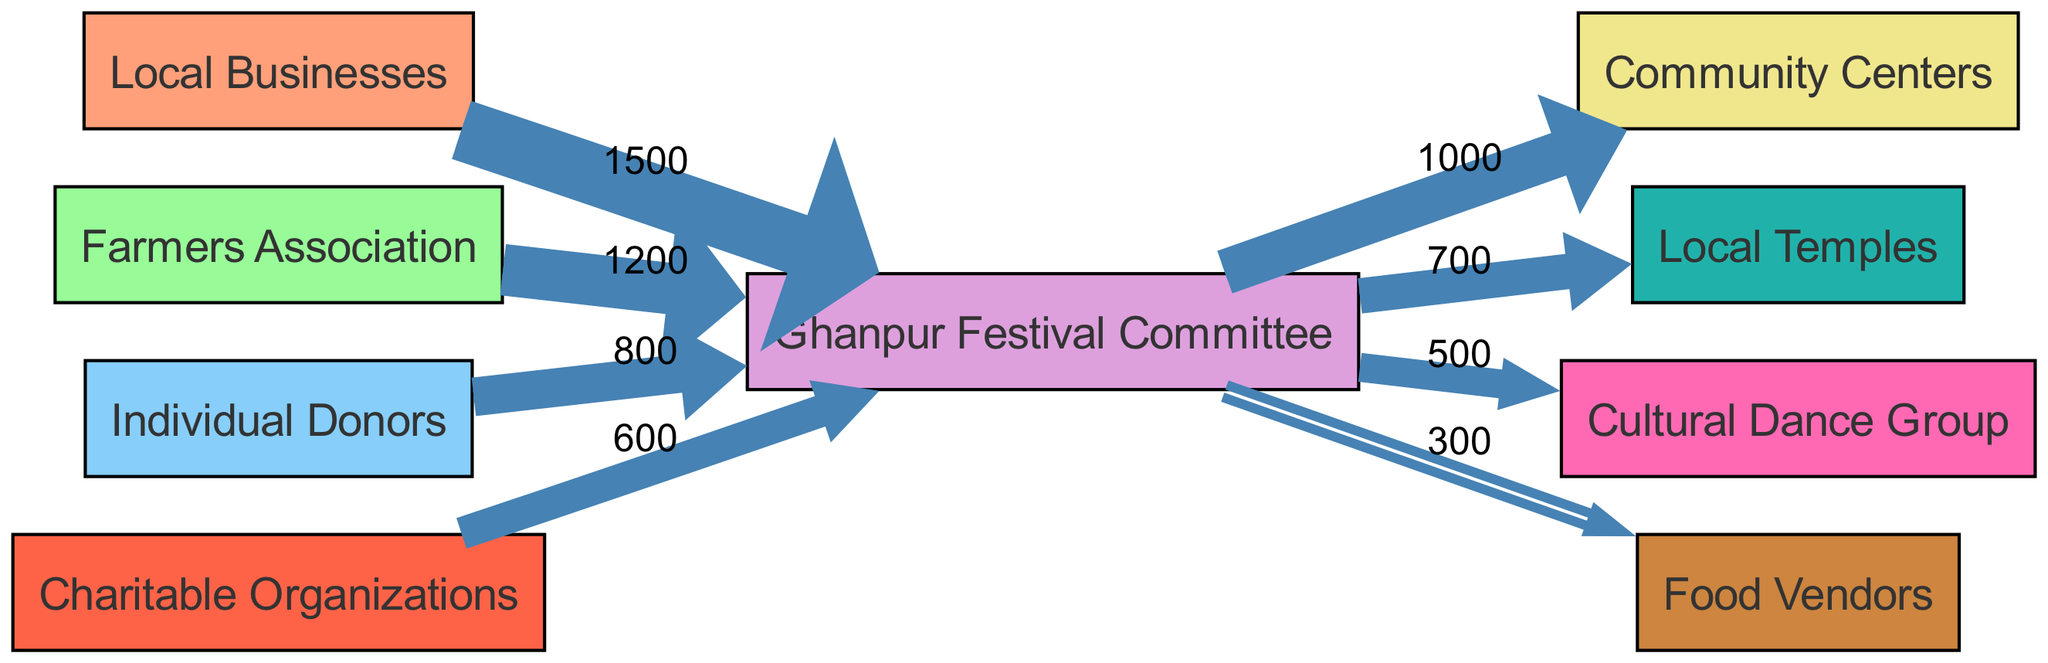What is the total amount contributed by Local Businesses? According to the diagram, Local Businesses contribute a total of 1500 towards the Ghanpur Festival Committee. This value is clearly indicated next to the flow from Local Businesses to the Ghanpur Festival Committee.
Answer: 1500 How much did Individual Donors contribute overall? The diagram shows that Individual Donors contributed a total of 800, as illustrated in the flow from Individual Donors to the Ghanpur Festival Committee.
Answer: 800 Which beneficiary receives the highest amount from the Ghanpur Festival Committee? By following the flows from the Ghanpur Festival Committee, we see that Community Centers receive the highest amount of 1000, making them the primary beneficiary among the listed options.
Answer: Community Centers What is the total amount given to Local Temples? The diagram specifies that Local Temples receive a contribution of 700 from the Ghanpur Festival Committee, as indicated in the flow.
Answer: 700 How many sources are there in this diagram? The diagram lists multiple sources that contribute donations; specifically, there are four distinct sources: Local Businesses, Farmers Association, Individual Donors, and Charitable Organizations.
Answer: 4 Which group provides the second highest contribution to the Ghanpur Festival Committee? According to the diagram, the Farmers Association, which contributes 1200, provides the second highest contribution, ranking just below Local Businesses.
Answer: Farmers Association What is the total amount allocated to Food Vendors? The diagram shows that Food Vendors receive a total of 300 from the Ghanpur Festival Committee, which is a direct correspondence of funds to this group.
Answer: 300 Who are the two main beneficiaries of the contributions made to the Ghanpur Festival Committee? Based on the flows from the Ghanpur Festival Committee, the two main beneficiaries are Community Centers and Local Temples, receiving 1000 and 700, respectively.
Answer: Community Centers and Local Temples Which source has the least contribution? By examining the diagram's flows, it's clear that Food Vendors receive the least contribution, totaling 300, compared to the other sources.
Answer: Food Vendors 